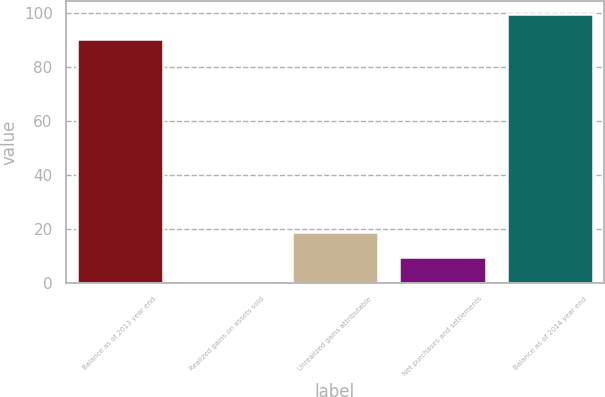Convert chart. <chart><loc_0><loc_0><loc_500><loc_500><bar_chart><fcel>Balance as of 2013 year end<fcel>Realized gains on assets sold<fcel>Unrealized gains attributable<fcel>Net purchases and settlements<fcel>Balance as of 2014 year end<nl><fcel>90.3<fcel>0.6<fcel>18.78<fcel>9.69<fcel>99.39<nl></chart> 